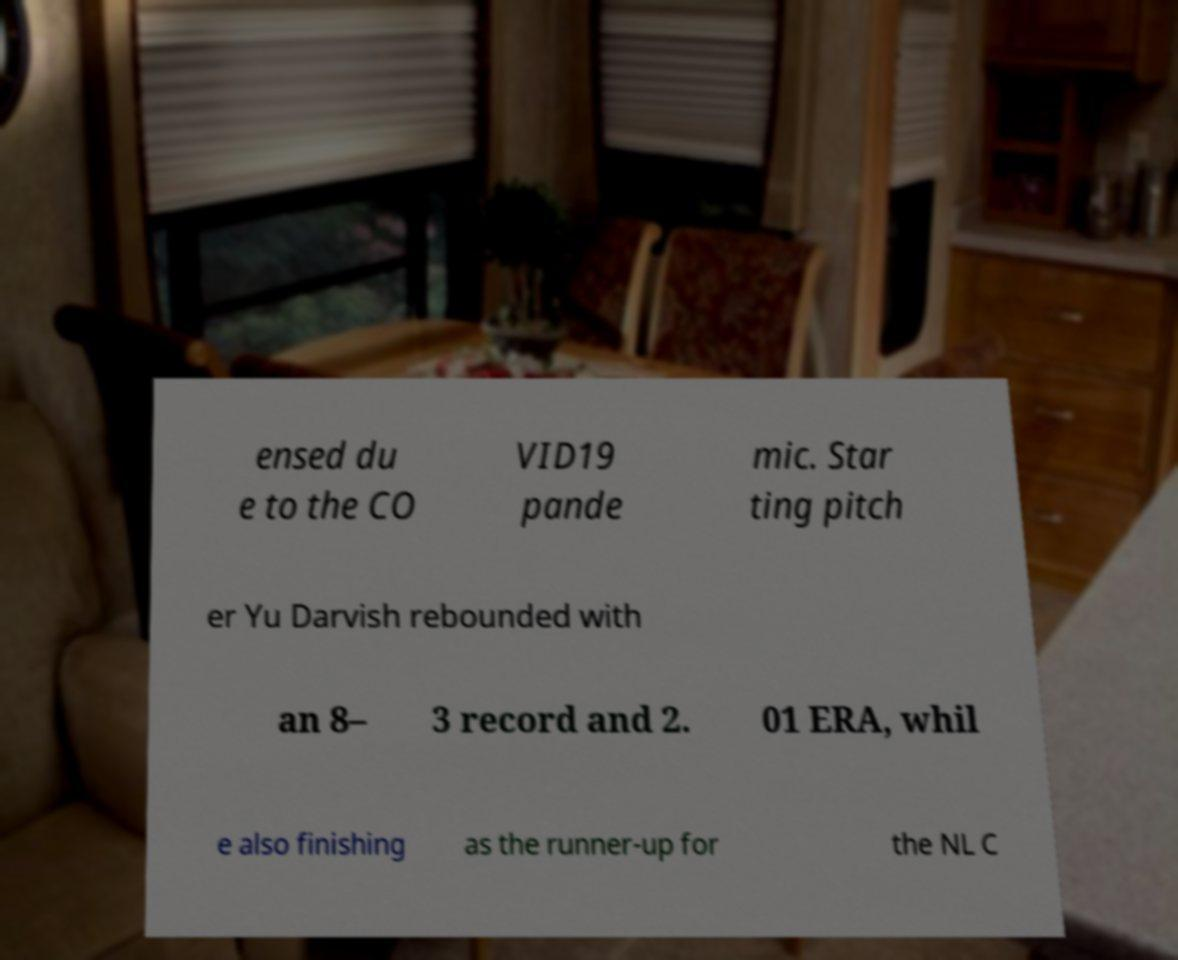Please identify and transcribe the text found in this image. ensed du e to the CO VID19 pande mic. Star ting pitch er Yu Darvish rebounded with an 8– 3 record and 2. 01 ERA, whil e also finishing as the runner-up for the NL C 